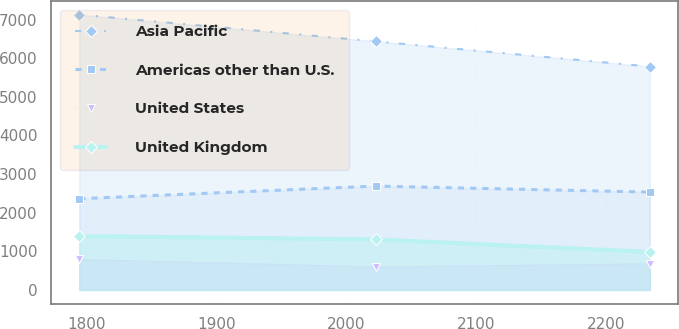Convert chart to OTSL. <chart><loc_0><loc_0><loc_500><loc_500><line_chart><ecel><fcel>Asia Pacific<fcel>Americas other than U.S.<fcel>United States<fcel>United Kingdom<nl><fcel>1794.79<fcel>7127.36<fcel>2361.83<fcel>795.44<fcel>1394.06<nl><fcel>2022.56<fcel>6435.41<fcel>2688.15<fcel>603.32<fcel>1307.54<nl><fcel>2233.17<fcel>5783.86<fcel>2532.77<fcel>680.58<fcel>983.47<nl></chart> 